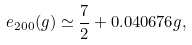<formula> <loc_0><loc_0><loc_500><loc_500>e _ { 2 0 0 } ( g ) \simeq \frac { 7 } { 2 } + 0 . 0 4 0 6 7 6 g ,</formula> 